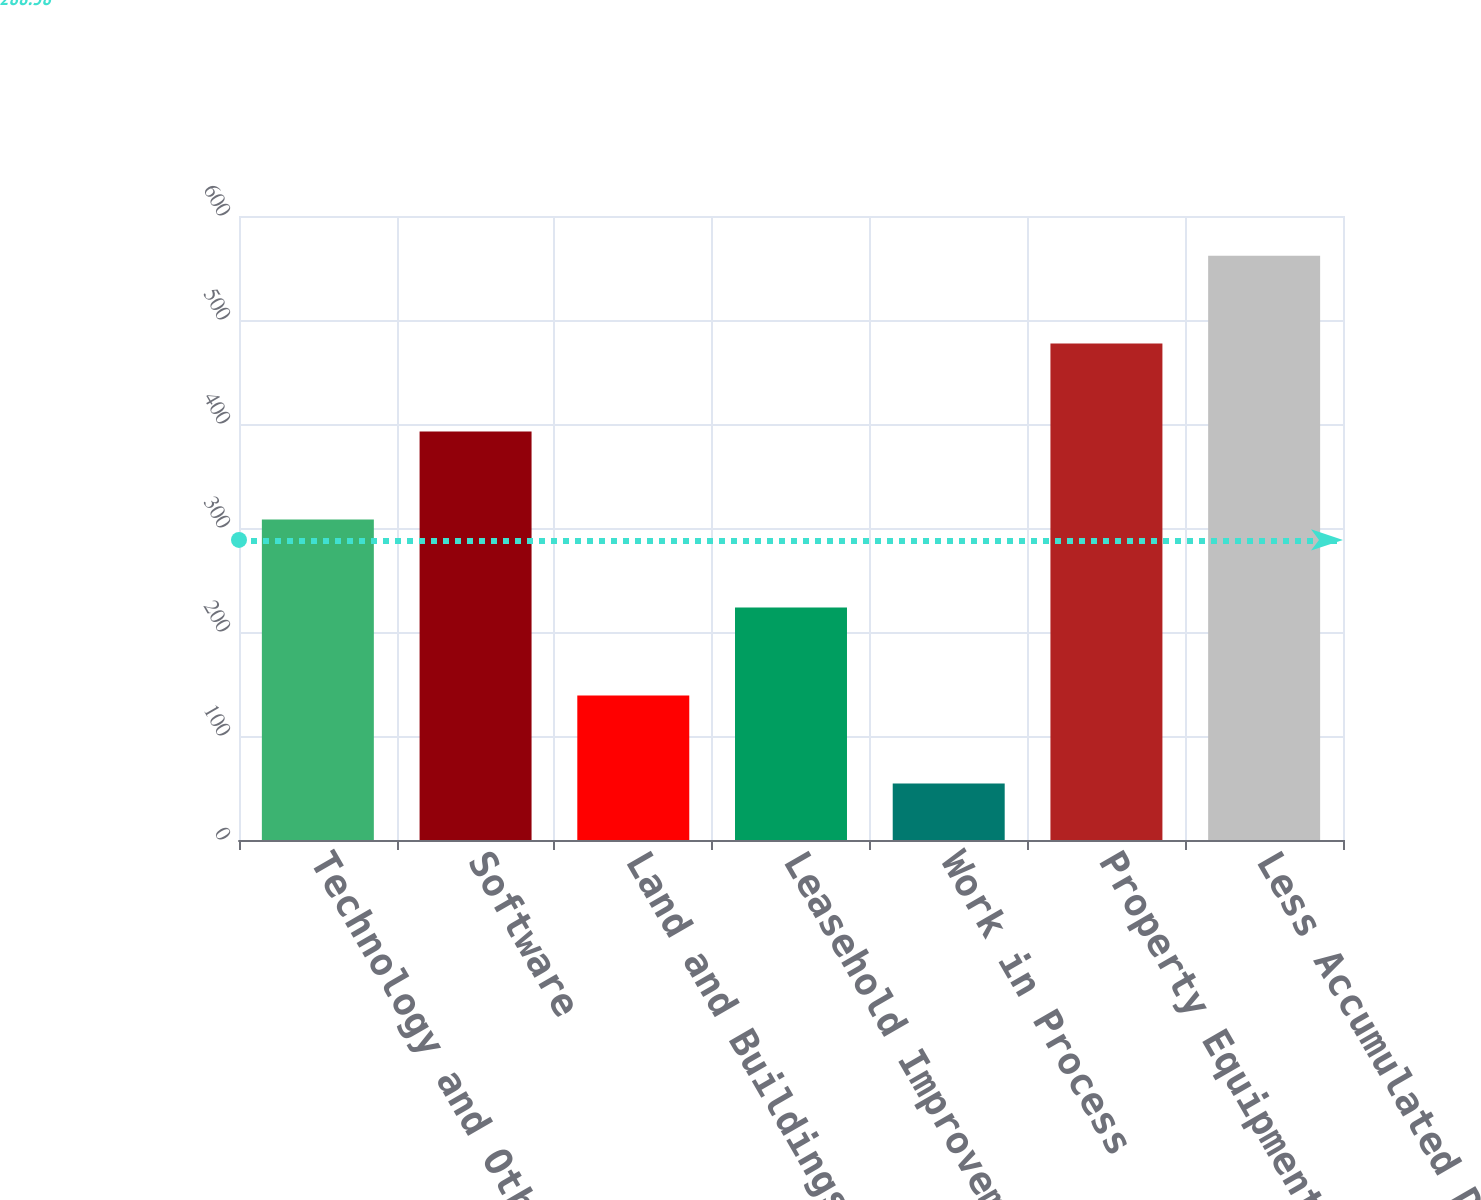<chart> <loc_0><loc_0><loc_500><loc_500><bar_chart><fcel>Technology and Other Equipment<fcel>Software<fcel>Land and Buildings<fcel>Leasehold Improvements<fcel>Work in Process<fcel>Property Equipment and<fcel>Less Accumulated Depreciation<nl><fcel>308.14<fcel>392.72<fcel>138.98<fcel>223.56<fcel>54.4<fcel>477.3<fcel>561.88<nl></chart> 